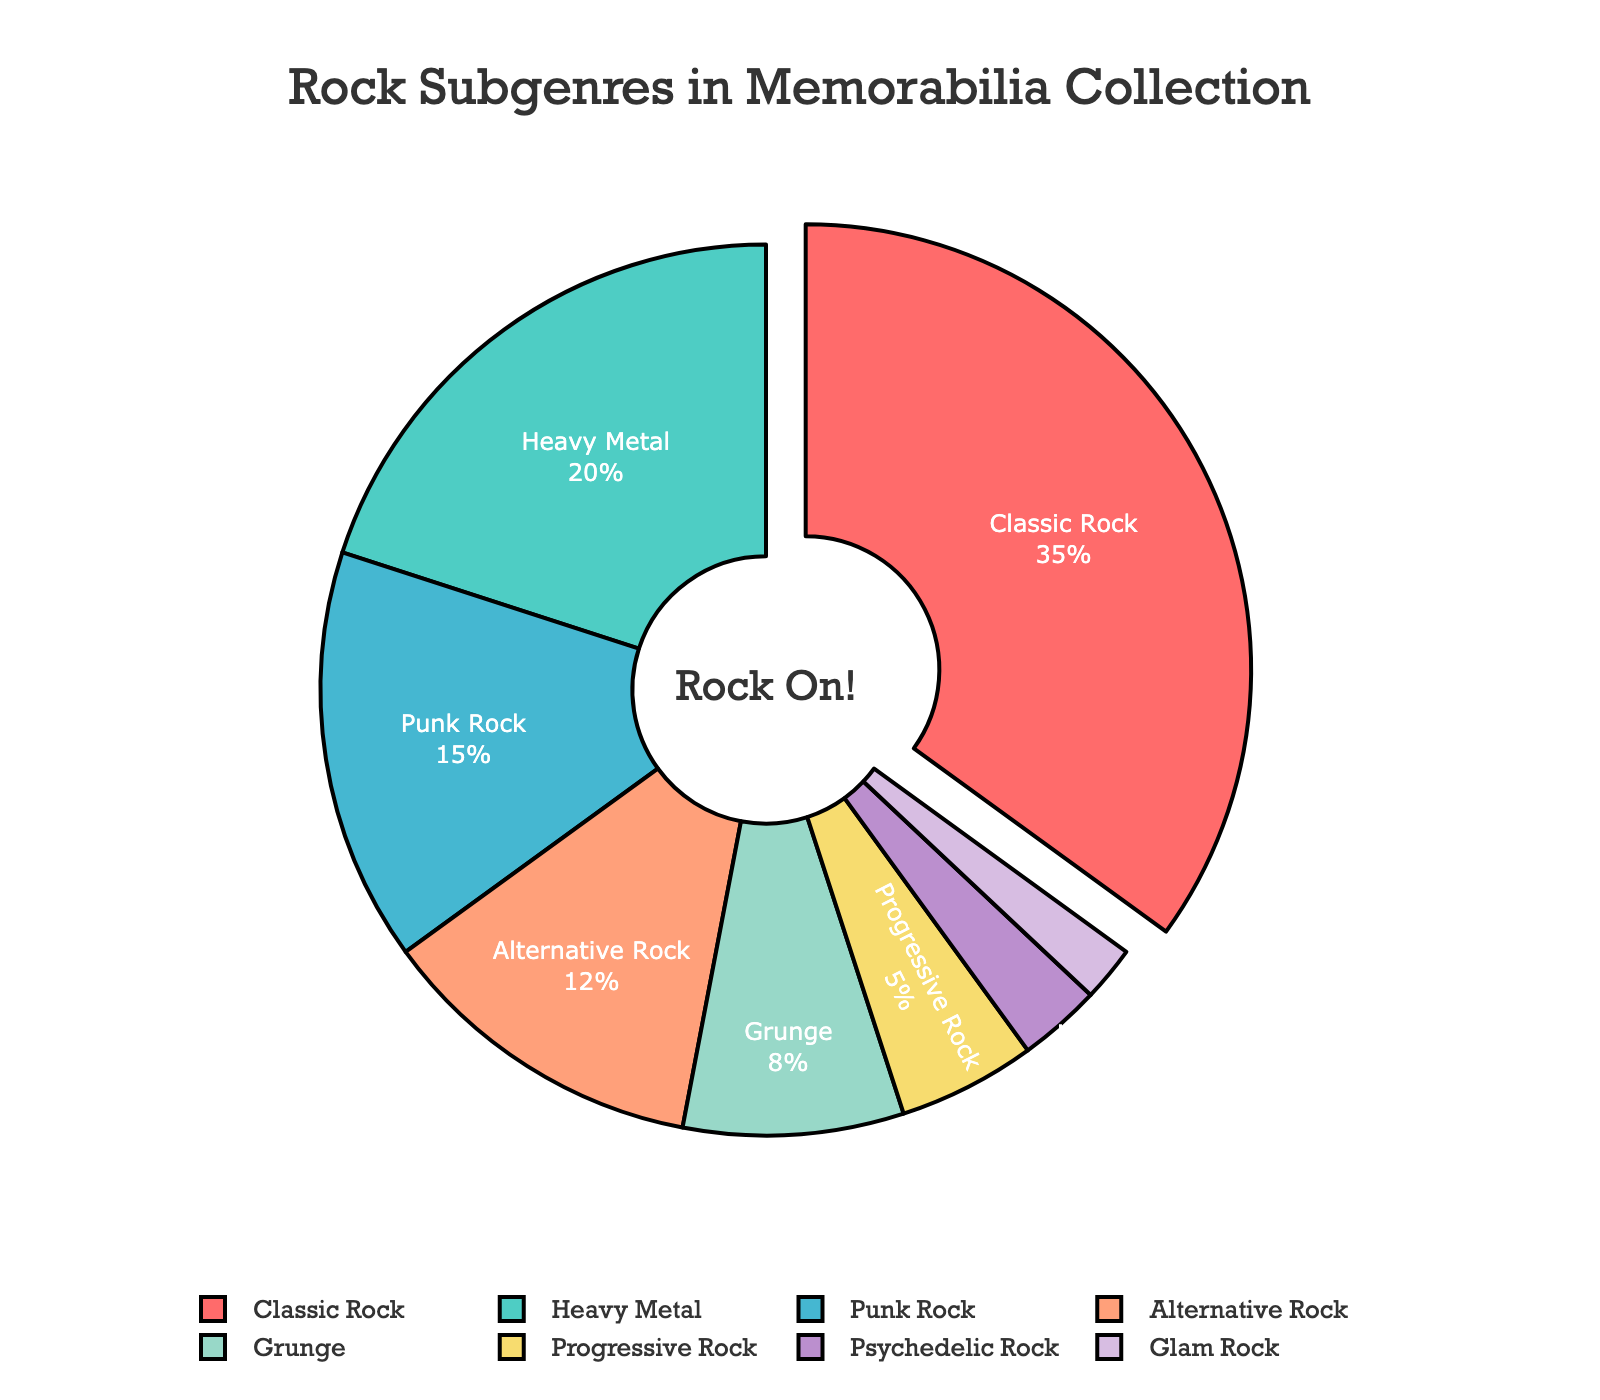What is the proportion of classic rock memorabilia in the collection? The proportion of classic rock memorabilia in the collection can be determined by looking at the segment labeled "Classic Rock" and its corresponding percentage value in the pie chart.
Answer: 35% Which subgenre has the smallest proportion in the collection, and what is that proportion? To find the subgenre with the smallest proportion, look for the smallest slice of the pie chart and identify its label and percentage value.
Answer: Glam Rock, 2% How much more prevalent is classic rock memorabilia than glam rock memorabilia? Calculate the difference in percentage between classic rock and glam rock by subtracting the percentage of glam rock from that of classic rock.
Answer: 33% Which two subgenres together make up approximately 50% of the memorabilia collection? Identify the two subgenres whose percentages sum up to approximately 50% by adding up their proportions. In this case, classic rock (35%) and heavy metal (20%) sum up to 55%, but heavy metal and punk rock (20% + 15%) sum up to 35%. So, this is not the answer. The closest pair is the largest category, classic rock, plus the next largest, heavy metal.
Answer: Classic Rock and Heavy Metal Is punk rock memorabilia more common than alternative rock memorabilia? Compare the percentage values of punk rock and alternative rock in the pie chart.
Answer: Yes What proportion of the collection is made up of progressive rock and psychedelic rock memorabilia combined? Add the percentages of progressive rock (5%) and psychedelic rock (3%) to get the combined proportion.
Answer: 8% How does the proportion of grunge memorabilia compare to that of heavy metal? Compare the percentage values of grunge (8%) and heavy metal (20%) from the pie chart and see which is larger and by how much. In this case, heavy metal is 12% more prevalent than grunge.
Answer: Heavy metal is 12% more prevalent Which subgenre is represented by the smallest slice of the pie chart? Find the smallest slice in the graphical representation and identify the corresponding subgenre.
Answer: Glam Rock What is the sum of the proportions of punk rock, alternative rock, and grunge memorabilia? Add the percentage values of punk rock (15%), alternative rock (12%), and grunge (8%) to get the total proportion.
Answer: 35% What color is used to represent heavy metal memorabilia in the pie chart? Identify the color associated with the "Heavy Metal" label in the chart.
Answer: Light green 